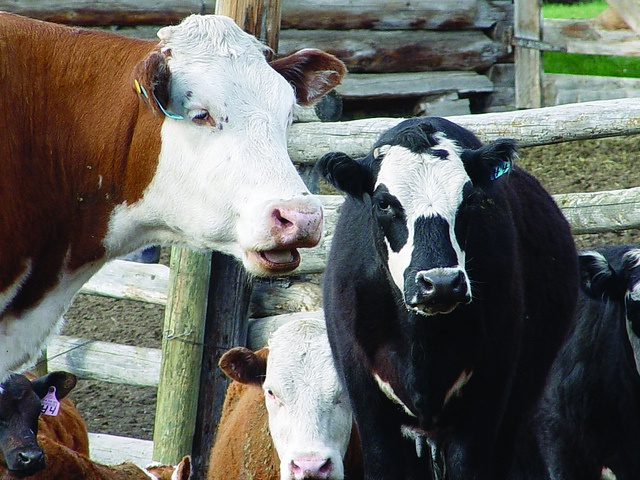Describe the objects in this image and their specific colors. I can see cow in gray, lightgray, black, maroon, and darkgray tones, cow in gray, black, white, and navy tones, cow in gray, white, tan, darkgray, and black tones, cow in gray, black, navy, and blue tones, and cow in gray, black, and maroon tones in this image. 